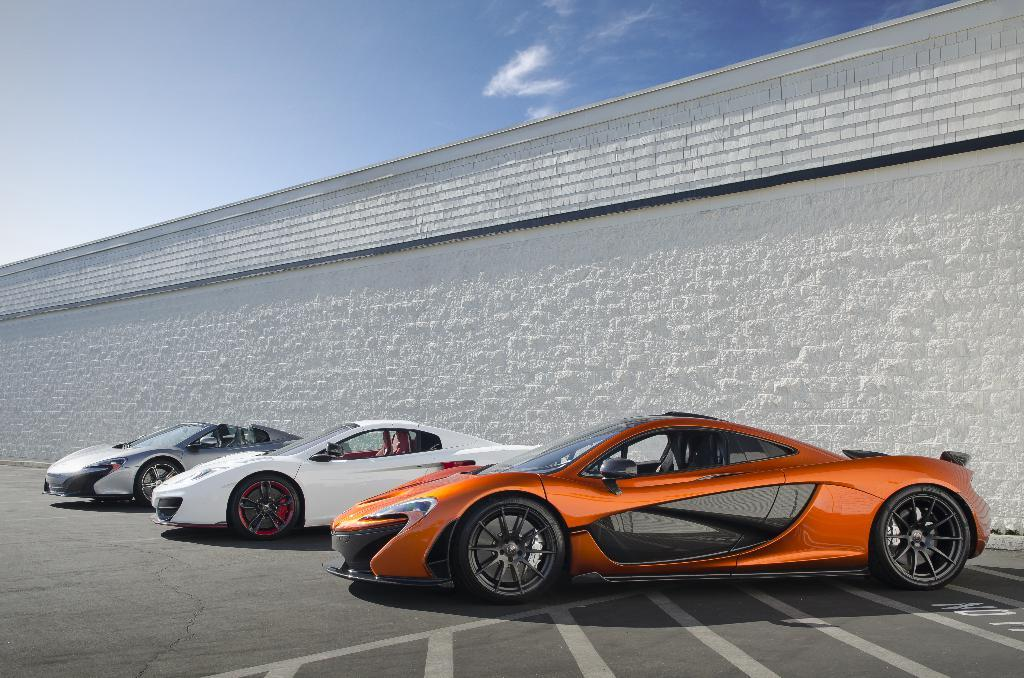How many cars can be seen on the road in the image? There are three cars on the road in the image. What is the color of the wall visible in the image? The wall in the image is white. What is visible at the top of the image? The sky is visible at the top of the image. Can you tell me how many times the celery sneezes in the image? There is no celery or sneezing present in the image. 